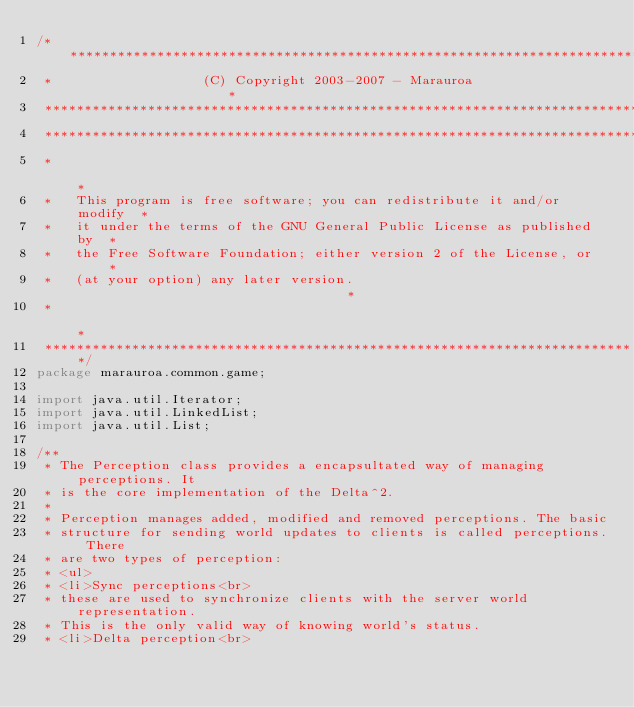<code> <loc_0><loc_0><loc_500><loc_500><_Java_>/***************************************************************************
 *                   (C) Copyright 2003-2007 - Marauroa                    *
 ***************************************************************************
 ***************************************************************************
 *                                                                         *
 *   This program is free software; you can redistribute it and/or modify  *
 *   it under the terms of the GNU General Public License as published by  *
 *   the Free Software Foundation; either version 2 of the License, or     *
 *   (at your option) any later version.                                   *
 *                                                                         *
 ***************************************************************************/
package marauroa.common.game;

import java.util.Iterator;
import java.util.LinkedList;
import java.util.List;

/**
 * The Perception class provides a encapsultated way of managing perceptions. It
 * is the core implementation of the Delta^2.
 *
 * Perception manages added, modified and removed perceptions. The basic
 * structure for sending world updates to clients is called perceptions. There
 * are two types of perception:
 * <ul>
 * <li>Sync perceptions<br>
 * these are used to synchronize clients with the server world representation.
 * This is the only valid way of knowing world's status.
 * <li>Delta perception<br></code> 